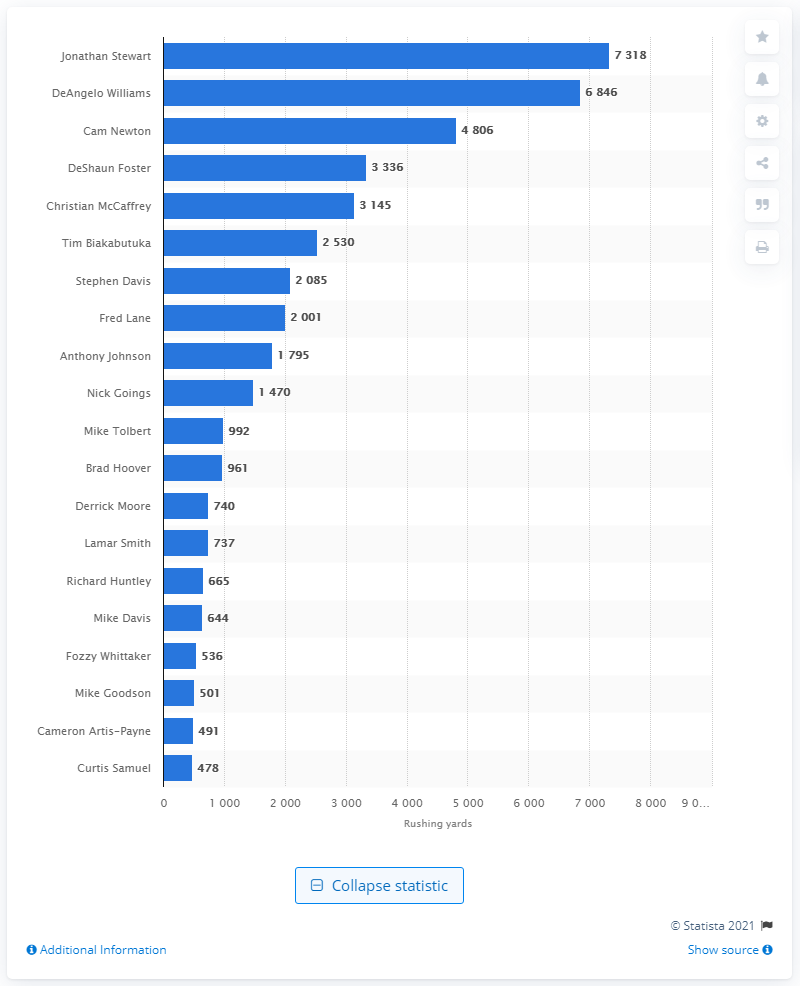Outline some significant characteristics in this image. The Carolina Panthers' all-time career rushing leader is Jonathan Stewart, who has amassed a total of 7,318 rushing yards during his tenure with the team. 